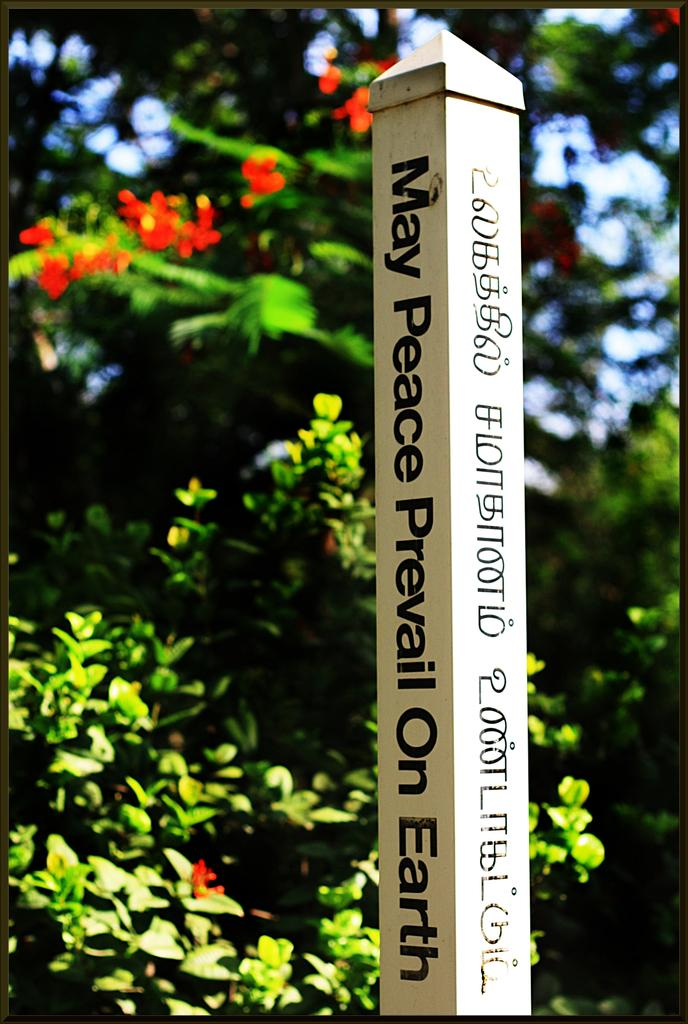What is the main object in the image? There is a pole in the image. What is written or depicted on the pole? There is text on the pole. What can be seen in the background of the image? There are trees and flowers in the background of the image. What type of decision can be seen being made by the horn in the image? There is no horn present in the image, so it is not possible to determine what decision might be made. 